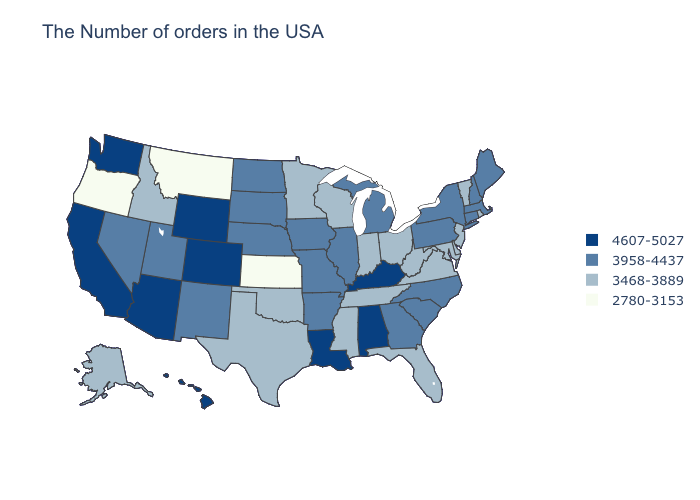Name the states that have a value in the range 2780-3153?
Give a very brief answer. Kansas, Montana, Oregon. Does Oregon have the lowest value in the West?
Give a very brief answer. Yes. Among the states that border Kentucky , does Virginia have the highest value?
Be succinct. No. What is the lowest value in the USA?
Concise answer only. 2780-3153. Name the states that have a value in the range 3958-4437?
Quick response, please. Maine, Massachusetts, New Hampshire, Connecticut, New York, Pennsylvania, North Carolina, South Carolina, Georgia, Michigan, Illinois, Missouri, Arkansas, Iowa, Nebraska, South Dakota, North Dakota, New Mexico, Utah, Nevada. What is the value of North Dakota?
Be succinct. 3958-4437. What is the value of Delaware?
Short answer required. 3468-3889. Does Arizona have the highest value in the West?
Be succinct. Yes. Which states have the highest value in the USA?
Write a very short answer. Kentucky, Alabama, Louisiana, Wyoming, Colorado, Arizona, California, Washington, Hawaii. Name the states that have a value in the range 3958-4437?
Give a very brief answer. Maine, Massachusetts, New Hampshire, Connecticut, New York, Pennsylvania, North Carolina, South Carolina, Georgia, Michigan, Illinois, Missouri, Arkansas, Iowa, Nebraska, South Dakota, North Dakota, New Mexico, Utah, Nevada. What is the value of West Virginia?
Concise answer only. 3468-3889. Does Missouri have the same value as Michigan?
Be succinct. Yes. Name the states that have a value in the range 3468-3889?
Give a very brief answer. Rhode Island, Vermont, New Jersey, Delaware, Maryland, Virginia, West Virginia, Ohio, Florida, Indiana, Tennessee, Wisconsin, Mississippi, Minnesota, Oklahoma, Texas, Idaho, Alaska. Name the states that have a value in the range 3468-3889?
Quick response, please. Rhode Island, Vermont, New Jersey, Delaware, Maryland, Virginia, West Virginia, Ohio, Florida, Indiana, Tennessee, Wisconsin, Mississippi, Minnesota, Oklahoma, Texas, Idaho, Alaska. Which states have the lowest value in the USA?
Quick response, please. Kansas, Montana, Oregon. 